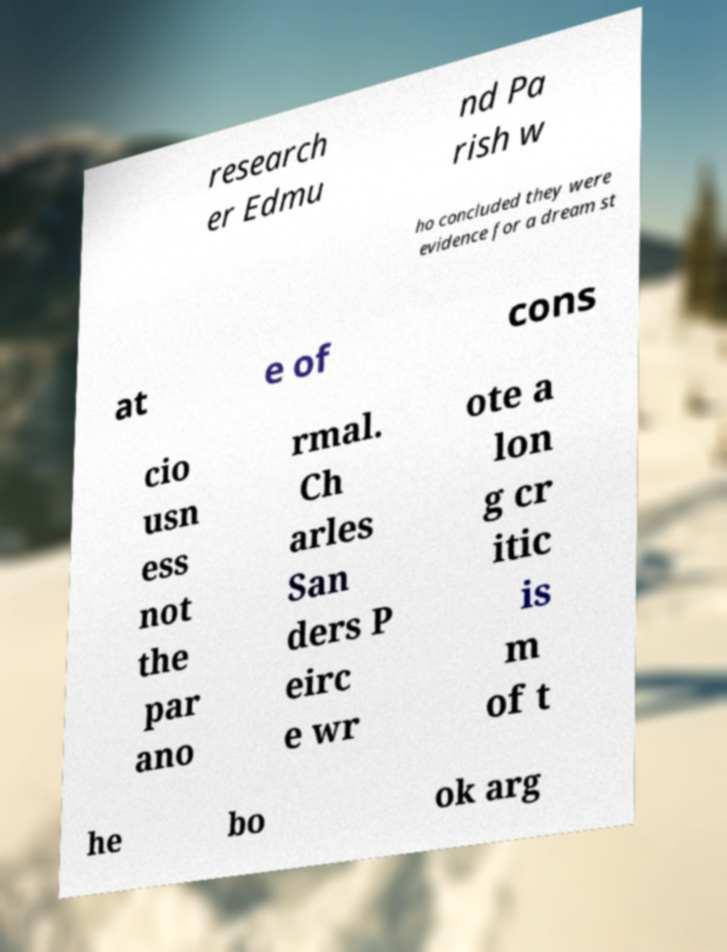Please identify and transcribe the text found in this image. research er Edmu nd Pa rish w ho concluded they were evidence for a dream st at e of cons cio usn ess not the par ano rmal. Ch arles San ders P eirc e wr ote a lon g cr itic is m of t he bo ok arg 